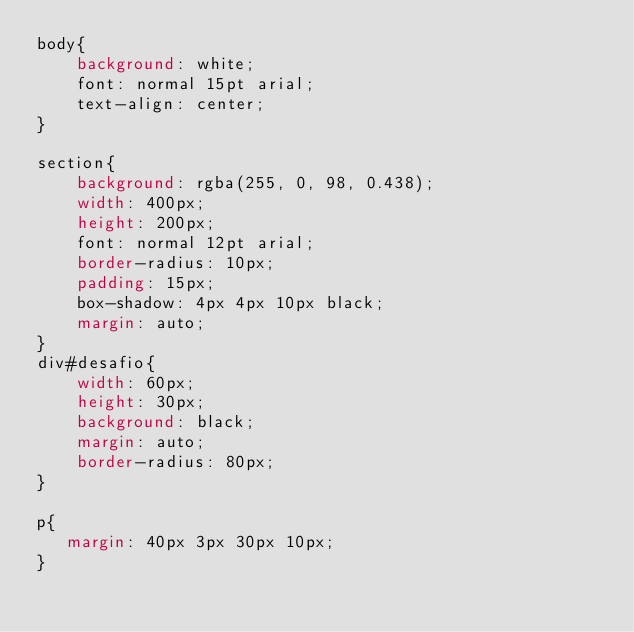Convert code to text. <code><loc_0><loc_0><loc_500><loc_500><_CSS_>body{
    background: white;
    font: normal 15pt arial;
    text-align: center;
}

section{
    background: rgba(255, 0, 98, 0.438);
    width: 400px;
    height: 200px;
    font: normal 12pt arial;
    border-radius: 10px;
    padding: 15px;
    box-shadow: 4px 4px 10px black;
    margin: auto;
}
div#desafio{
    width: 60px;
    height: 30px;
    background: black;
    margin: auto;
    border-radius: 80px;
}

p{
   margin: 40px 3px 30px 10px;
}</code> 